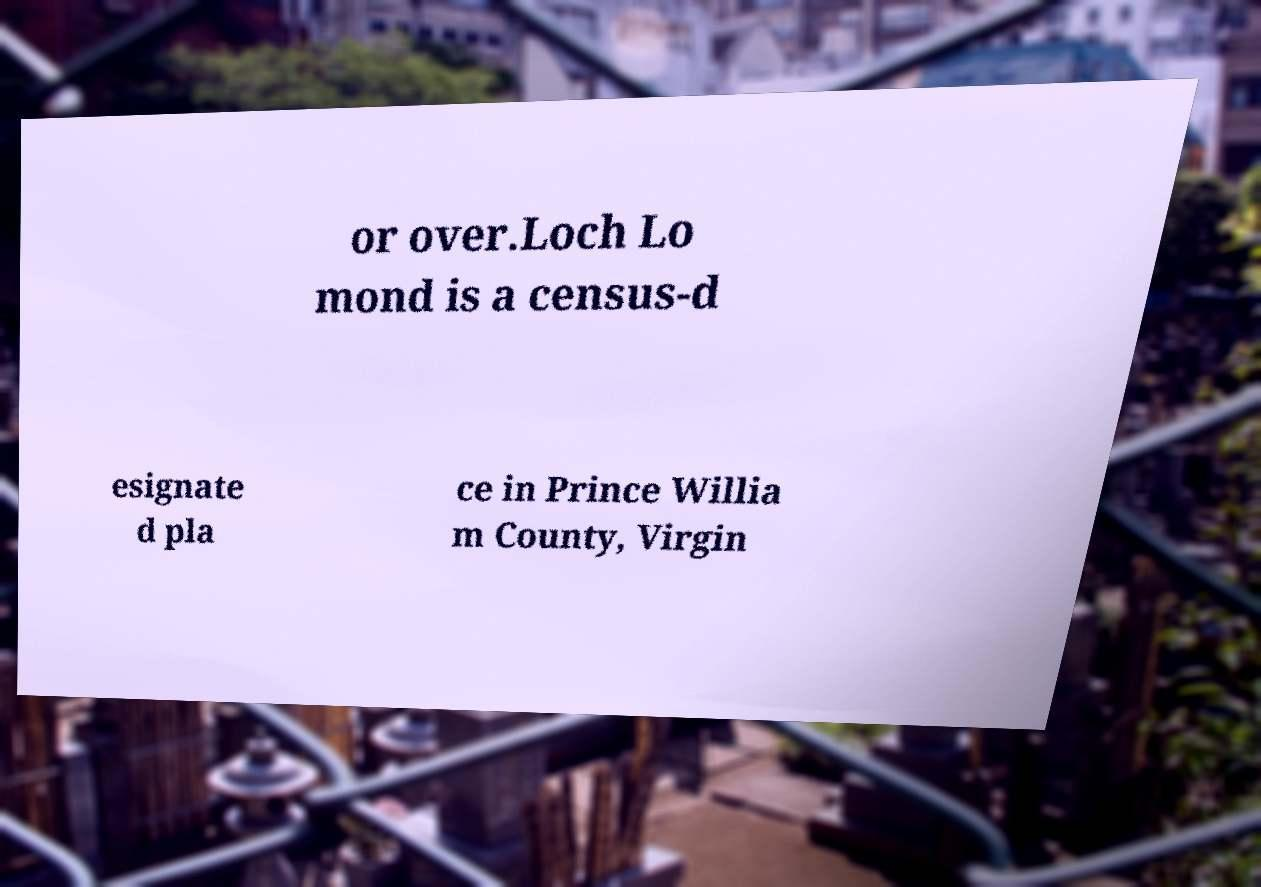What messages or text are displayed in this image? I need them in a readable, typed format. or over.Loch Lo mond is a census-d esignate d pla ce in Prince Willia m County, Virgin 